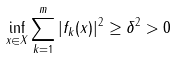Convert formula to latex. <formula><loc_0><loc_0><loc_500><loc_500>\inf _ { x \in X } \sum _ { k = 1 } ^ { m } | f _ { k } ( x ) | ^ { 2 } \geq \delta ^ { 2 } > 0</formula> 